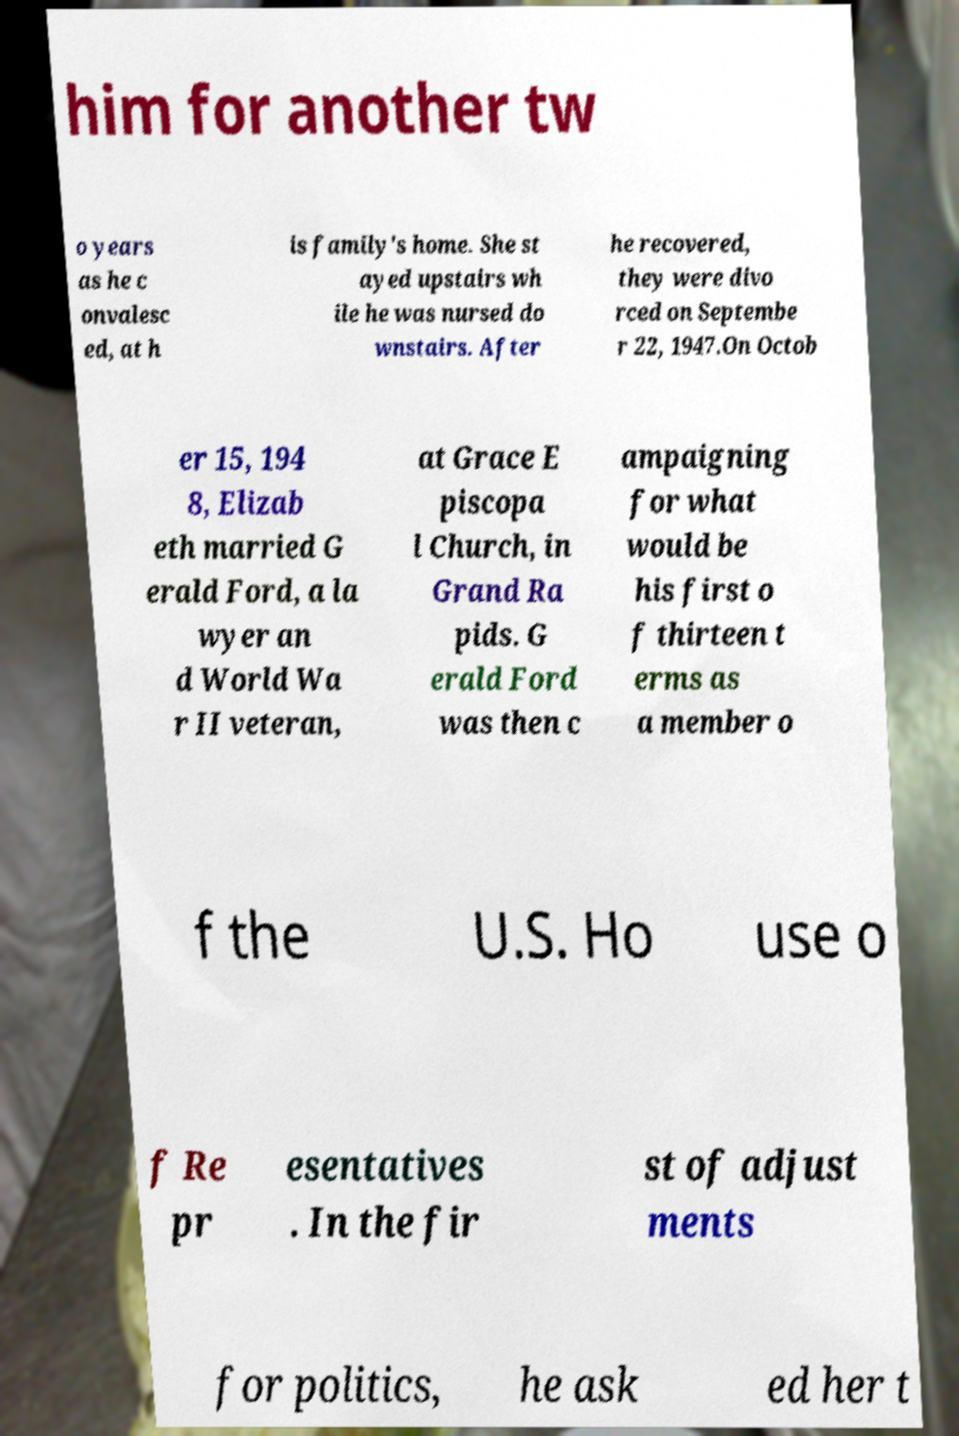Please read and relay the text visible in this image. What does it say? him for another tw o years as he c onvalesc ed, at h is family's home. She st ayed upstairs wh ile he was nursed do wnstairs. After he recovered, they were divo rced on Septembe r 22, 1947.On Octob er 15, 194 8, Elizab eth married G erald Ford, a la wyer an d World Wa r II veteran, at Grace E piscopa l Church, in Grand Ra pids. G erald Ford was then c ampaigning for what would be his first o f thirteen t erms as a member o f the U.S. Ho use o f Re pr esentatives . In the fir st of adjust ments for politics, he ask ed her t 